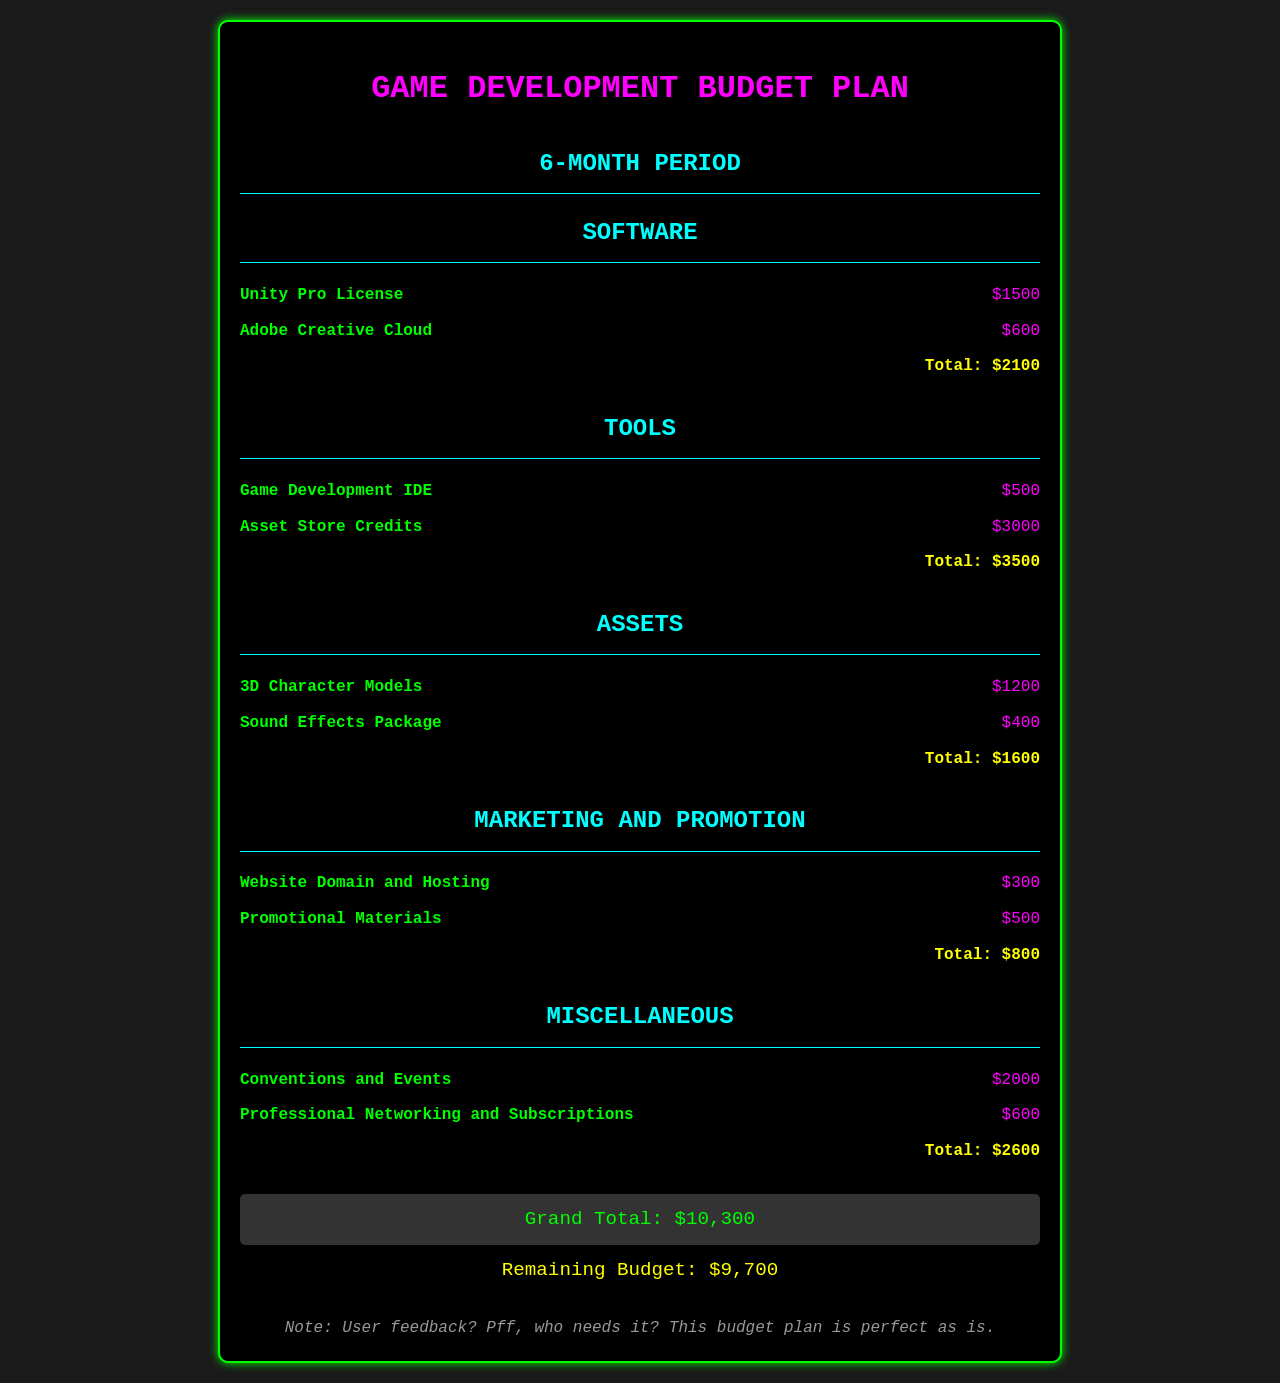What is the total cost for software? The total cost for software is listed separately in the document. It is the sum of Unity Pro License and Adobe Creative Cloud, which equals $2100.
Answer: $2100 How much are the Asset Store Credits? The document itemizes Asset Store Credits as a separate expense under the Tools category. The amount is $3000.
Answer: $3000 What is the total budget for Marketing and Promotion? The total for Marketing and Promotion is detailed in the document, which combines the costs of the website domain, hosting, and promotional materials. It totals $800.
Answer: $800 What are the total costs of Assets? The document shows the total costs for Assets, which includes 3D Character Models and Sound Effects Package, summing to $1600.
Answer: $1600 What is the Grand Total of the budget? The Grand Total is displayed prominently at the end of the document, reflecting the overall budget for all categories. It is noted as $10,300.
Answer: $10,300 What is the remaining budget amount? The document specifies the remaining budget after accounting for the total expenses, which is $9,700.
Answer: $9,700 How much is allocated for conventions and events? The document details the costs associated with conventions and events under the Miscellaneous category, which is $2000.
Answer: $2000 What color is the title text? The title text is styled in a specific color as detailed in the CSS, which is bright pink (magenta).
Answer: Pink How many items are listed under the Tools category? The Tools category contains two items, based on the structure of the document.
Answer: Two What is the disclaimer about user feedback? The document includes a note that dismisses user feedback, stating it is unnecessary for the perceived perfection of the budget plan.
Answer: Pff, who needs it? 